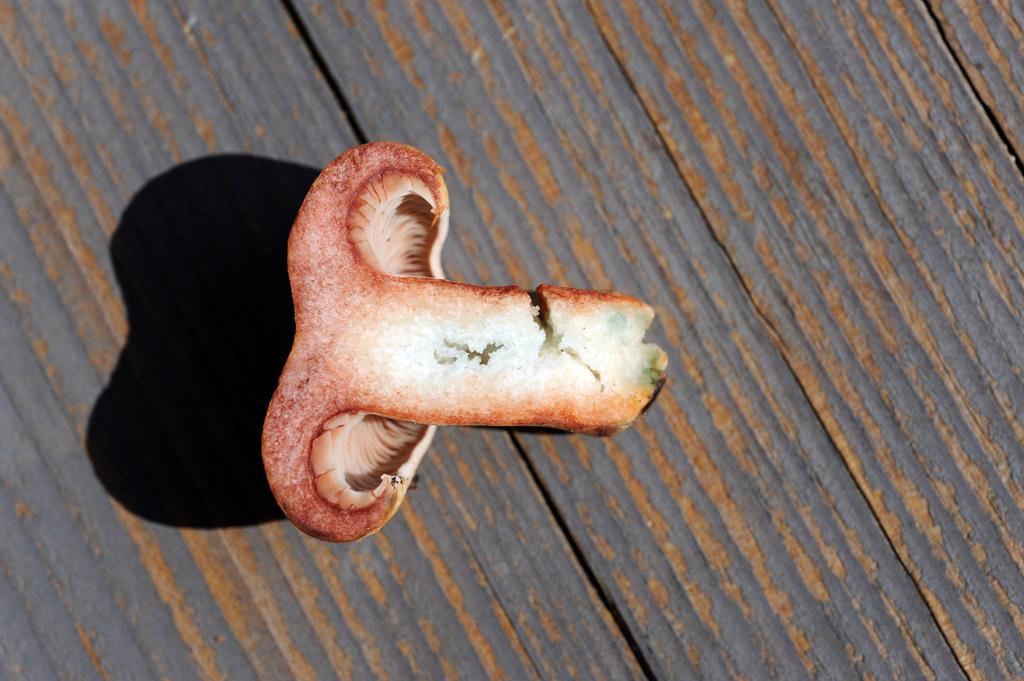What is present on the table in the image? There is a mushroom slice on the table. Can you describe the table in the image? The table is the main surface visible in the image. Is there a squirrel sitting on the table telling a joke in the image? There is no squirrel or joke present in the image; it only features a table with a mushroom slice on it. 